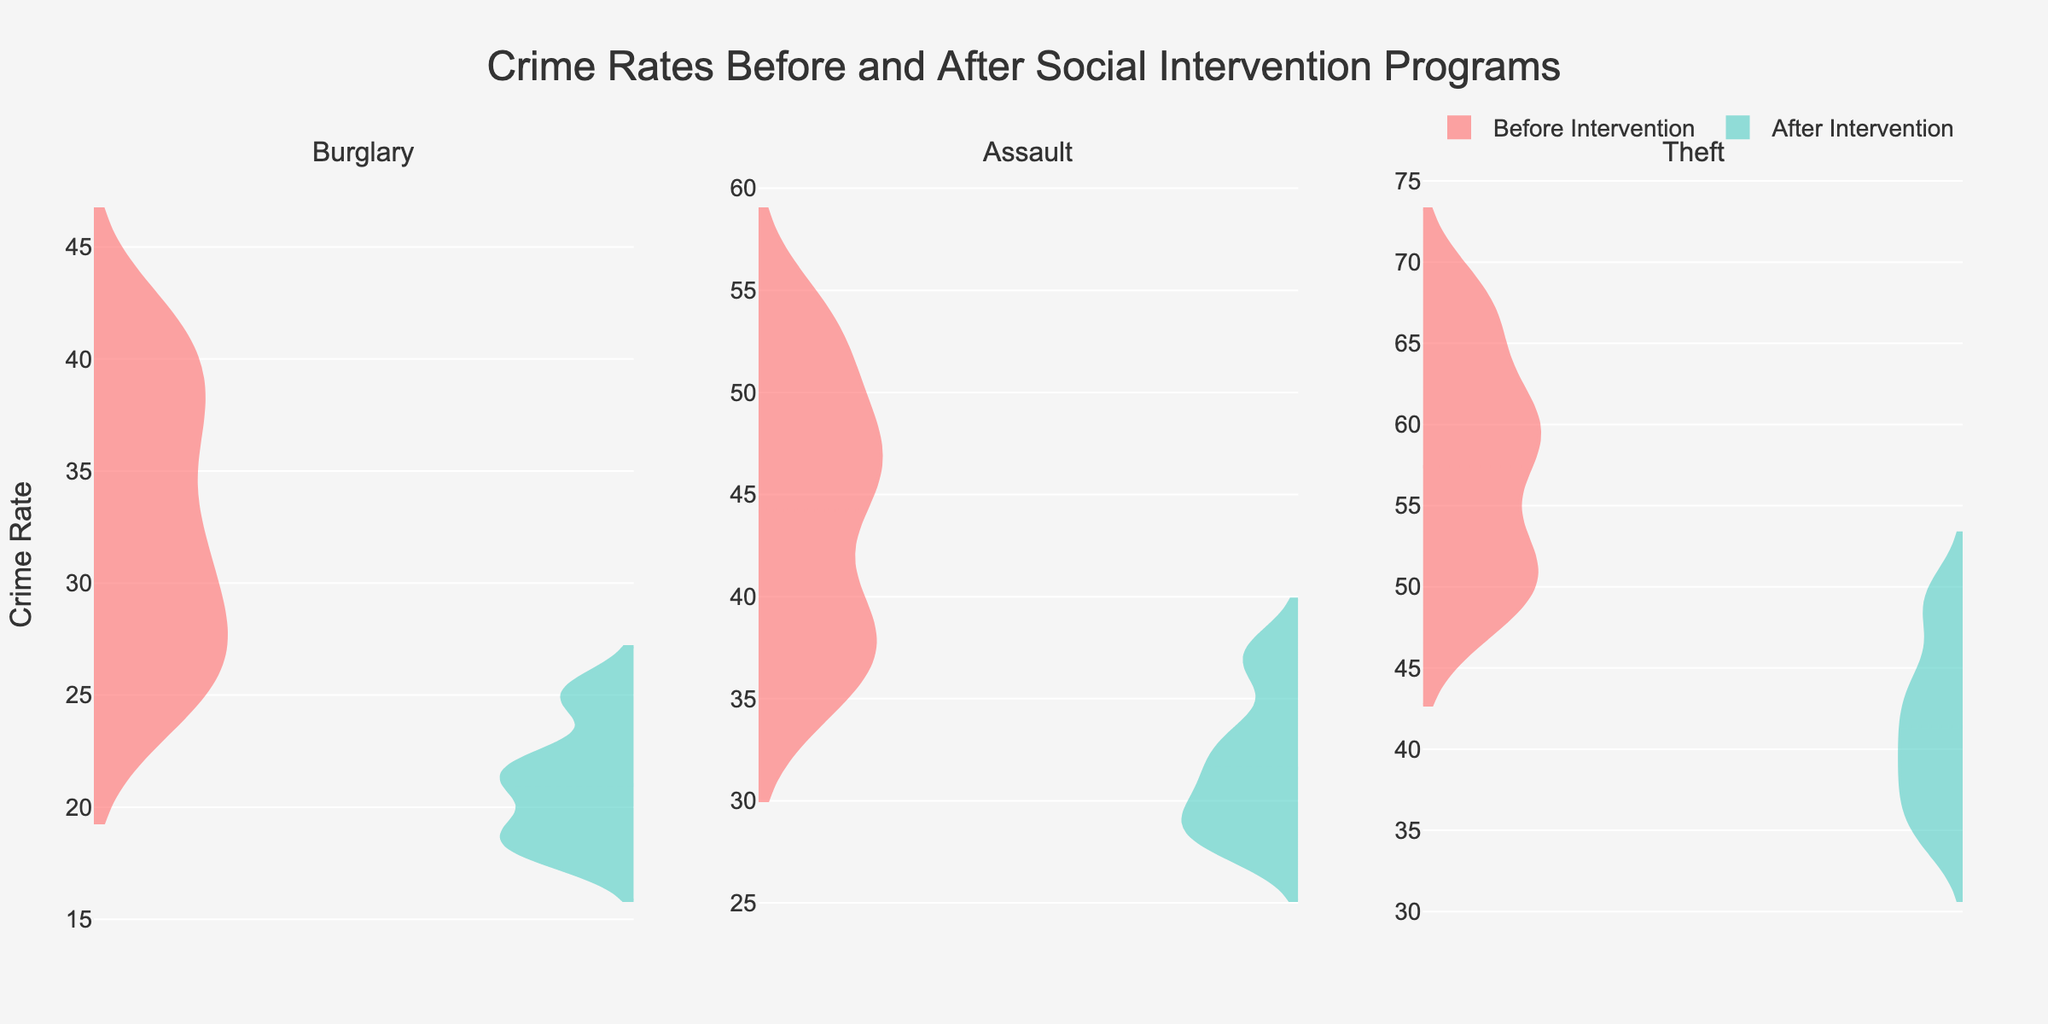what is the predominant color used for the visualization of the 'before intervention' data? The 'before intervention' data is visualized using a primarily red color. This can be identified by observing the side of the violins that represent the 'before intervention' period across the different crime types.
Answer: red What's the title of the figure? The title of the figure is easily observable at the top of the figure layout.
Answer: Crime Rates Before and After Social Intervention Programs What is the average difference in burglary rates in Oakwood before and after the intervention program? To find the average difference, take the burglary rate in Oakwood before the intervention (32) and after the intervention (18). The difference here is 32 - 18 = 14.
Answer: 14 Which neighborhood exhibited the largest reduction in assault rates after the intervention? Reviewing each neighborhood for their assault rates before and after intervention:
- Oakwood: 45 to 29 (reduction 16)
- Riverside: 39 to 31 (reduction 8)
- Meadowbrook: 53 to 37 (reduction 16)
- Pine Hills: 48 to 33 (reduction 15)
- Sunnyside: 36 to 28 (reduction 8)
Both Oakwood and Meadowbrook show the largest reduction, each reducing by 16.
Answer: Oakwood and Meadowbrook Does the density plot for theft cases show more density after the intervention in most neighborhoods? By analyzing the density plots for theft cases, the violin plots after the intervention generally show peaks that align lower than the peaks before intervention, indicating that there are fewer thefts rates in most neighborhoods after the intervention program.
Answer: Yes Are the crime rates for assault higher in Pine Hills before or after the intervention? By observing the density plots for assaults in Pine Hills, the values before the intervention are higher compared to after the intervention, indicating a reduction post-intervention.
Answer: Before Which crime type had the smallest change in average rates across all neighborhoods after the intervention? By calculating the average change for each crime type across all neighborhoods:
- Burglary: ((32-18) + (28-22) + (41-25) + (37-21) + (25-19))/5 = 14+6+16+16+6 = 58/5 = 11.6
- Assault: ((45-29) + (39-31) + (53-37) + (48-33) + (36-28))/5 = 16+8+16+15+8 = 63/5 = 12.6
- Theft: ((58-41) + (52-38) + (67-49) + (61-44) + (49-35))/5 = 17+14+18+17+14 = 80/5 = 16
Burglary shows the smallest average change, with 11.6.
Answer: Burglary After the intervention, did any crime type have intersection points where before and after intervention density plots overlap in Sunnyside? By observing density plots for each crime type in Sunnyside:
- Burglary: Overlaps slightly.
- Assault: Overlaps slightly.
- Theft: Overlaps somewhat more.
All three crime types had some level of overlap in density plots after the intervention.
Answer: Yes 